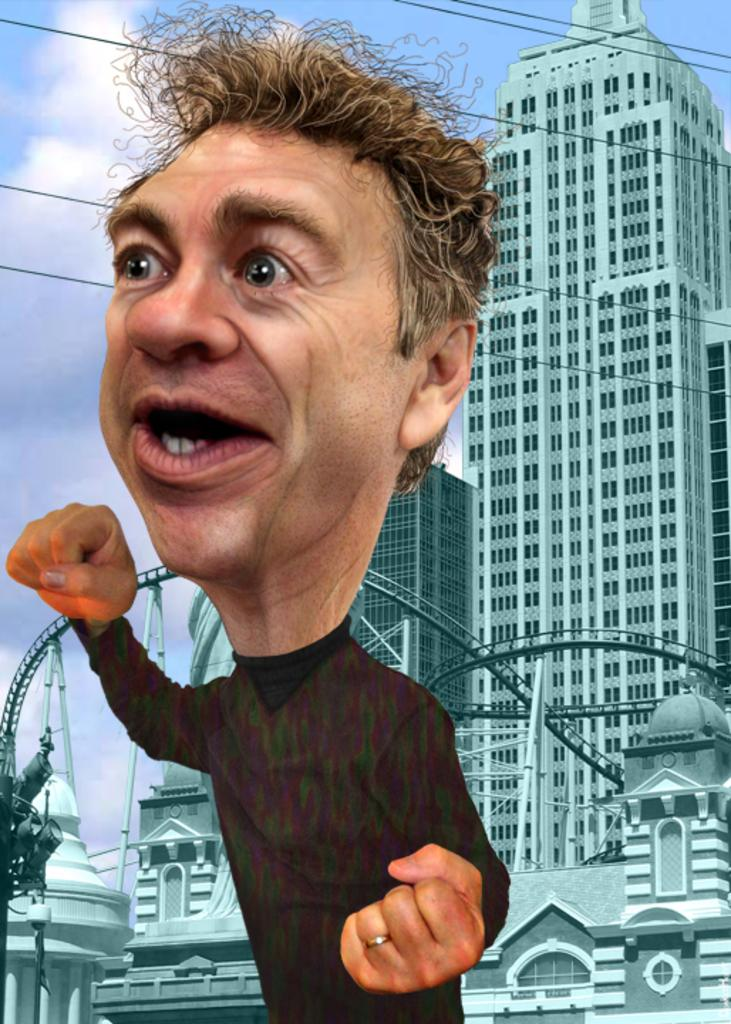Who is present in the image? There is a man in the image. What type of structures can be seen in the image? There are buildings in the image. What else can be seen in the image besides the man and buildings? There are wires in the image. What is visible in the background of the image? The sky is visible in the background of the image, and there are clouds in the sky. How many sheep are visible in the image? There are no sheep present in the image. What is located on the back of the man in the image? The provided facts do not mention anything about the man's back, so we cannot answer this question. 